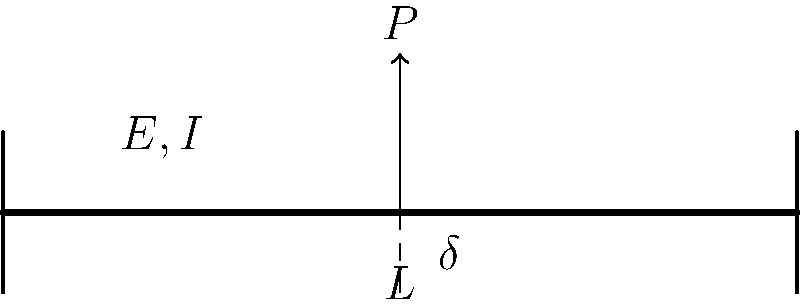For the simply supported beam shown above with length $L$, elastic modulus $E$, and moment of inertia $I$, subjected to a point load $P$ at its midspan, derive an expression for the maximum deflection $\delta$. How would this deflection change if the beam ends were fixed instead of simply supported? To solve this problem, we'll follow these steps:

1. For a simply supported beam with a point load at midspan:
   The maximum deflection occurs at the midpoint and is given by the equation:
   $$\delta = \frac{PL^3}{48EI}$$

   Derivation:
   a) The general equation for beam deflection is:
      $$\frac{d^2y}{dx^2} = \frac{M(x)}{EI}$$
   b) For this loading condition, the moment equation is:
      $$M(x) = \frac{Px}{2}$$ for $0 \leq x \leq L/2$
   c) Integrate twice and apply boundary conditions to get the deflection equation.

2. For a fixed-end beam with a point load at midspan:
   The maximum deflection is given by:
   $$\delta = \frac{PL^3}{192EI}$$

3. Comparing the two cases:
   $$\frac{\delta_{fixed}}{\delta_{simply supported}} = \frac{1}{4}$$

   This means the deflection for the fixed-end beam is 1/4 of the simply supported beam.

4. Explanation of the difference:
   - Fixed ends provide more constraint, reducing the overall deflection.
   - The fixed ends create negative moments at the supports, which counteract the positive moment at the midspan, resulting in a stiffer overall system.

5. From a data science perspective, this relationship demonstrates how boundary conditions significantly affect structural behavior, which could be an important feature in machine learning models for structural analysis.
Answer: $\delta = \frac{PL^3}{48EI}$ for simply supported; $\delta = \frac{PL^3}{192EI}$ for fixed ends. Fixed-end deflection is 1/4 of simply supported. 